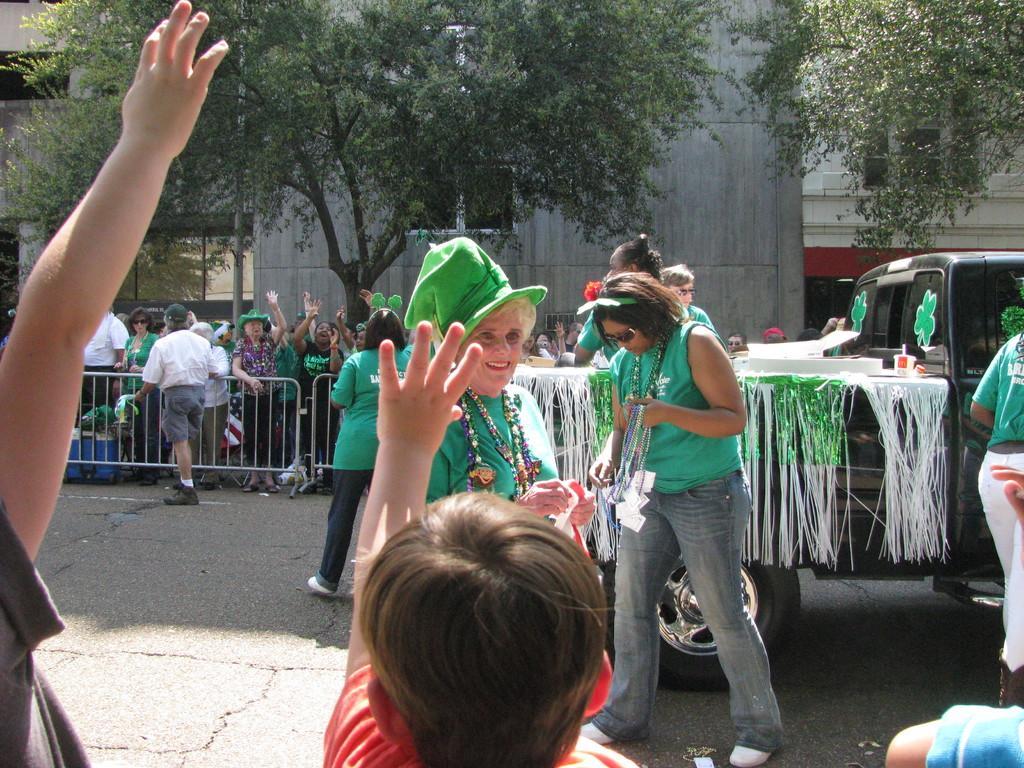In one or two sentences, can you explain what this image depicts? In this image there is a vehicle which is decorated with some papers is on the road. A woman wearing green shirt is having a cap. Beside there is a woman standing on road. She is holding few chains in her hand. Few persons are on the road. Behind the fence there are few persons standing, behind them there are few trees and buildings. Bottom of image there are few persons. 